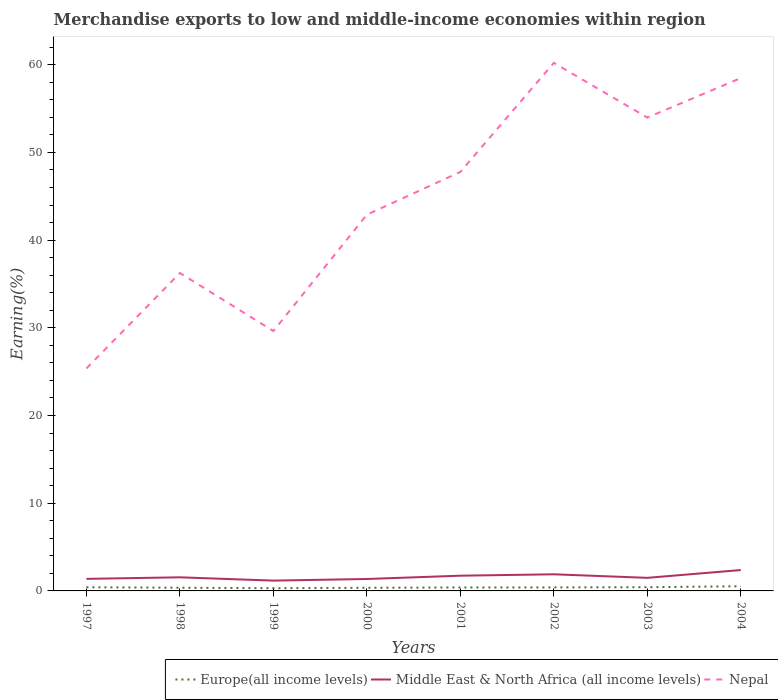How many different coloured lines are there?
Provide a short and direct response. 3. Is the number of lines equal to the number of legend labels?
Give a very brief answer. Yes. Across all years, what is the maximum percentage of amount earned from merchandise exports in Middle East & North Africa (all income levels)?
Give a very brief answer. 1.18. What is the total percentage of amount earned from merchandise exports in Nepal in the graph?
Give a very brief answer. -10.88. What is the difference between the highest and the second highest percentage of amount earned from merchandise exports in Middle East & North Africa (all income levels)?
Keep it short and to the point. 1.2. What is the difference between the highest and the lowest percentage of amount earned from merchandise exports in Europe(all income levels)?
Make the answer very short. 4. How many lines are there?
Your answer should be very brief. 3. How many years are there in the graph?
Keep it short and to the point. 8. What is the difference between two consecutive major ticks on the Y-axis?
Your response must be concise. 10. Does the graph contain any zero values?
Provide a succinct answer. No. Does the graph contain grids?
Your answer should be very brief. No. What is the title of the graph?
Your response must be concise. Merchandise exports to low and middle-income economies within region. Does "Guatemala" appear as one of the legend labels in the graph?
Provide a short and direct response. No. What is the label or title of the X-axis?
Your answer should be very brief. Years. What is the label or title of the Y-axis?
Make the answer very short. Earning(%). What is the Earning(%) in Europe(all income levels) in 1997?
Give a very brief answer. 0.42. What is the Earning(%) in Middle East & North Africa (all income levels) in 1997?
Make the answer very short. 1.38. What is the Earning(%) in Nepal in 1997?
Ensure brevity in your answer.  25.37. What is the Earning(%) in Europe(all income levels) in 1998?
Your answer should be very brief. 0.37. What is the Earning(%) of Middle East & North Africa (all income levels) in 1998?
Provide a short and direct response. 1.55. What is the Earning(%) in Nepal in 1998?
Offer a terse response. 36.25. What is the Earning(%) in Europe(all income levels) in 1999?
Your answer should be very brief. 0.31. What is the Earning(%) in Middle East & North Africa (all income levels) in 1999?
Your answer should be compact. 1.18. What is the Earning(%) in Nepal in 1999?
Keep it short and to the point. 29.63. What is the Earning(%) of Europe(all income levels) in 2000?
Give a very brief answer. 0.36. What is the Earning(%) of Middle East & North Africa (all income levels) in 2000?
Keep it short and to the point. 1.36. What is the Earning(%) in Nepal in 2000?
Provide a short and direct response. 42.9. What is the Earning(%) of Europe(all income levels) in 2001?
Offer a terse response. 0.39. What is the Earning(%) in Middle East & North Africa (all income levels) in 2001?
Ensure brevity in your answer.  1.74. What is the Earning(%) of Nepal in 2001?
Make the answer very short. 47.78. What is the Earning(%) of Europe(all income levels) in 2002?
Ensure brevity in your answer.  0.4. What is the Earning(%) of Middle East & North Africa (all income levels) in 2002?
Offer a very short reply. 1.9. What is the Earning(%) of Nepal in 2002?
Your response must be concise. 60.22. What is the Earning(%) in Europe(all income levels) in 2003?
Provide a short and direct response. 0.42. What is the Earning(%) of Middle East & North Africa (all income levels) in 2003?
Provide a succinct answer. 1.49. What is the Earning(%) in Nepal in 2003?
Offer a terse response. 53.98. What is the Earning(%) of Europe(all income levels) in 2004?
Keep it short and to the point. 0.53. What is the Earning(%) in Middle East & North Africa (all income levels) in 2004?
Provide a succinct answer. 2.38. What is the Earning(%) in Nepal in 2004?
Offer a very short reply. 58.48. Across all years, what is the maximum Earning(%) in Europe(all income levels)?
Provide a succinct answer. 0.53. Across all years, what is the maximum Earning(%) in Middle East & North Africa (all income levels)?
Keep it short and to the point. 2.38. Across all years, what is the maximum Earning(%) in Nepal?
Keep it short and to the point. 60.22. Across all years, what is the minimum Earning(%) of Europe(all income levels)?
Your answer should be very brief. 0.31. Across all years, what is the minimum Earning(%) in Middle East & North Africa (all income levels)?
Your answer should be very brief. 1.18. Across all years, what is the minimum Earning(%) of Nepal?
Give a very brief answer. 25.37. What is the total Earning(%) in Europe(all income levels) in the graph?
Your answer should be compact. 3.2. What is the total Earning(%) in Middle East & North Africa (all income levels) in the graph?
Make the answer very short. 12.97. What is the total Earning(%) of Nepal in the graph?
Your answer should be compact. 354.61. What is the difference between the Earning(%) of Europe(all income levels) in 1997 and that in 1998?
Provide a short and direct response. 0.05. What is the difference between the Earning(%) in Middle East & North Africa (all income levels) in 1997 and that in 1998?
Ensure brevity in your answer.  -0.18. What is the difference between the Earning(%) of Nepal in 1997 and that in 1998?
Offer a very short reply. -10.88. What is the difference between the Earning(%) of Europe(all income levels) in 1997 and that in 1999?
Offer a terse response. 0.11. What is the difference between the Earning(%) of Middle East & North Africa (all income levels) in 1997 and that in 1999?
Make the answer very short. 0.2. What is the difference between the Earning(%) of Nepal in 1997 and that in 1999?
Provide a succinct answer. -4.26. What is the difference between the Earning(%) in Europe(all income levels) in 1997 and that in 2000?
Offer a very short reply. 0.06. What is the difference between the Earning(%) in Middle East & North Africa (all income levels) in 1997 and that in 2000?
Give a very brief answer. 0.01. What is the difference between the Earning(%) of Nepal in 1997 and that in 2000?
Provide a succinct answer. -17.53. What is the difference between the Earning(%) in Europe(all income levels) in 1997 and that in 2001?
Ensure brevity in your answer.  0.02. What is the difference between the Earning(%) in Middle East & North Africa (all income levels) in 1997 and that in 2001?
Your response must be concise. -0.36. What is the difference between the Earning(%) of Nepal in 1997 and that in 2001?
Your response must be concise. -22.41. What is the difference between the Earning(%) of Europe(all income levels) in 1997 and that in 2002?
Your answer should be very brief. 0.02. What is the difference between the Earning(%) in Middle East & North Africa (all income levels) in 1997 and that in 2002?
Your response must be concise. -0.52. What is the difference between the Earning(%) of Nepal in 1997 and that in 2002?
Make the answer very short. -34.84. What is the difference between the Earning(%) in Europe(all income levels) in 1997 and that in 2003?
Your answer should be very brief. -0.01. What is the difference between the Earning(%) in Middle East & North Africa (all income levels) in 1997 and that in 2003?
Your answer should be very brief. -0.12. What is the difference between the Earning(%) of Nepal in 1997 and that in 2003?
Provide a short and direct response. -28.61. What is the difference between the Earning(%) of Europe(all income levels) in 1997 and that in 2004?
Your response must be concise. -0.12. What is the difference between the Earning(%) in Middle East & North Africa (all income levels) in 1997 and that in 2004?
Offer a terse response. -1. What is the difference between the Earning(%) of Nepal in 1997 and that in 2004?
Keep it short and to the point. -33.11. What is the difference between the Earning(%) in Europe(all income levels) in 1998 and that in 1999?
Your answer should be very brief. 0.06. What is the difference between the Earning(%) of Middle East & North Africa (all income levels) in 1998 and that in 1999?
Offer a very short reply. 0.38. What is the difference between the Earning(%) of Nepal in 1998 and that in 1999?
Ensure brevity in your answer.  6.61. What is the difference between the Earning(%) of Europe(all income levels) in 1998 and that in 2000?
Your answer should be compact. 0.01. What is the difference between the Earning(%) in Middle East & North Africa (all income levels) in 1998 and that in 2000?
Give a very brief answer. 0.19. What is the difference between the Earning(%) in Nepal in 1998 and that in 2000?
Give a very brief answer. -6.65. What is the difference between the Earning(%) of Europe(all income levels) in 1998 and that in 2001?
Offer a very short reply. -0.03. What is the difference between the Earning(%) of Middle East & North Africa (all income levels) in 1998 and that in 2001?
Your answer should be very brief. -0.19. What is the difference between the Earning(%) of Nepal in 1998 and that in 2001?
Make the answer very short. -11.53. What is the difference between the Earning(%) in Europe(all income levels) in 1998 and that in 2002?
Your answer should be very brief. -0.03. What is the difference between the Earning(%) in Middle East & North Africa (all income levels) in 1998 and that in 2002?
Offer a very short reply. -0.34. What is the difference between the Earning(%) in Nepal in 1998 and that in 2002?
Your answer should be compact. -23.97. What is the difference between the Earning(%) in Europe(all income levels) in 1998 and that in 2003?
Your response must be concise. -0.06. What is the difference between the Earning(%) of Middle East & North Africa (all income levels) in 1998 and that in 2003?
Keep it short and to the point. 0.06. What is the difference between the Earning(%) in Nepal in 1998 and that in 2003?
Your answer should be very brief. -17.73. What is the difference between the Earning(%) of Europe(all income levels) in 1998 and that in 2004?
Ensure brevity in your answer.  -0.17. What is the difference between the Earning(%) in Middle East & North Africa (all income levels) in 1998 and that in 2004?
Your response must be concise. -0.83. What is the difference between the Earning(%) in Nepal in 1998 and that in 2004?
Provide a short and direct response. -22.23. What is the difference between the Earning(%) of Europe(all income levels) in 1999 and that in 2000?
Offer a terse response. -0.05. What is the difference between the Earning(%) in Middle East & North Africa (all income levels) in 1999 and that in 2000?
Offer a very short reply. -0.19. What is the difference between the Earning(%) in Nepal in 1999 and that in 2000?
Your answer should be very brief. -13.27. What is the difference between the Earning(%) in Europe(all income levels) in 1999 and that in 2001?
Ensure brevity in your answer.  -0.08. What is the difference between the Earning(%) of Middle East & North Africa (all income levels) in 1999 and that in 2001?
Provide a succinct answer. -0.56. What is the difference between the Earning(%) of Nepal in 1999 and that in 2001?
Your answer should be compact. -18.14. What is the difference between the Earning(%) in Europe(all income levels) in 1999 and that in 2002?
Make the answer very short. -0.09. What is the difference between the Earning(%) in Middle East & North Africa (all income levels) in 1999 and that in 2002?
Ensure brevity in your answer.  -0.72. What is the difference between the Earning(%) of Nepal in 1999 and that in 2002?
Offer a very short reply. -30.58. What is the difference between the Earning(%) in Europe(all income levels) in 1999 and that in 2003?
Give a very brief answer. -0.12. What is the difference between the Earning(%) in Middle East & North Africa (all income levels) in 1999 and that in 2003?
Make the answer very short. -0.32. What is the difference between the Earning(%) of Nepal in 1999 and that in 2003?
Ensure brevity in your answer.  -24.34. What is the difference between the Earning(%) of Europe(all income levels) in 1999 and that in 2004?
Your response must be concise. -0.22. What is the difference between the Earning(%) of Middle East & North Africa (all income levels) in 1999 and that in 2004?
Offer a very short reply. -1.2. What is the difference between the Earning(%) in Nepal in 1999 and that in 2004?
Provide a short and direct response. -28.84. What is the difference between the Earning(%) in Europe(all income levels) in 2000 and that in 2001?
Your response must be concise. -0.03. What is the difference between the Earning(%) in Middle East & North Africa (all income levels) in 2000 and that in 2001?
Offer a terse response. -0.38. What is the difference between the Earning(%) of Nepal in 2000 and that in 2001?
Offer a terse response. -4.87. What is the difference between the Earning(%) of Europe(all income levels) in 2000 and that in 2002?
Keep it short and to the point. -0.04. What is the difference between the Earning(%) in Middle East & North Africa (all income levels) in 2000 and that in 2002?
Offer a very short reply. -0.53. What is the difference between the Earning(%) of Nepal in 2000 and that in 2002?
Keep it short and to the point. -17.31. What is the difference between the Earning(%) of Europe(all income levels) in 2000 and that in 2003?
Your answer should be compact. -0.07. What is the difference between the Earning(%) in Middle East & North Africa (all income levels) in 2000 and that in 2003?
Offer a very short reply. -0.13. What is the difference between the Earning(%) of Nepal in 2000 and that in 2003?
Your answer should be compact. -11.07. What is the difference between the Earning(%) in Europe(all income levels) in 2000 and that in 2004?
Keep it short and to the point. -0.17. What is the difference between the Earning(%) in Middle East & North Africa (all income levels) in 2000 and that in 2004?
Make the answer very short. -1.02. What is the difference between the Earning(%) in Nepal in 2000 and that in 2004?
Keep it short and to the point. -15.58. What is the difference between the Earning(%) in Europe(all income levels) in 2001 and that in 2002?
Ensure brevity in your answer.  -0.01. What is the difference between the Earning(%) of Middle East & North Africa (all income levels) in 2001 and that in 2002?
Offer a terse response. -0.16. What is the difference between the Earning(%) in Nepal in 2001 and that in 2002?
Provide a short and direct response. -12.44. What is the difference between the Earning(%) in Europe(all income levels) in 2001 and that in 2003?
Offer a very short reply. -0.03. What is the difference between the Earning(%) in Middle East & North Africa (all income levels) in 2001 and that in 2003?
Ensure brevity in your answer.  0.25. What is the difference between the Earning(%) in Nepal in 2001 and that in 2003?
Give a very brief answer. -6.2. What is the difference between the Earning(%) in Europe(all income levels) in 2001 and that in 2004?
Your answer should be compact. -0.14. What is the difference between the Earning(%) of Middle East & North Africa (all income levels) in 2001 and that in 2004?
Provide a succinct answer. -0.64. What is the difference between the Earning(%) in Nepal in 2001 and that in 2004?
Give a very brief answer. -10.7. What is the difference between the Earning(%) in Europe(all income levels) in 2002 and that in 2003?
Your answer should be very brief. -0.02. What is the difference between the Earning(%) in Middle East & North Africa (all income levels) in 2002 and that in 2003?
Keep it short and to the point. 0.4. What is the difference between the Earning(%) in Nepal in 2002 and that in 2003?
Your answer should be compact. 6.24. What is the difference between the Earning(%) in Europe(all income levels) in 2002 and that in 2004?
Keep it short and to the point. -0.13. What is the difference between the Earning(%) in Middle East & North Africa (all income levels) in 2002 and that in 2004?
Your answer should be compact. -0.48. What is the difference between the Earning(%) of Nepal in 2002 and that in 2004?
Your answer should be compact. 1.74. What is the difference between the Earning(%) of Europe(all income levels) in 2003 and that in 2004?
Your answer should be very brief. -0.11. What is the difference between the Earning(%) in Middle East & North Africa (all income levels) in 2003 and that in 2004?
Provide a succinct answer. -0.89. What is the difference between the Earning(%) of Nepal in 2003 and that in 2004?
Make the answer very short. -4.5. What is the difference between the Earning(%) in Europe(all income levels) in 1997 and the Earning(%) in Middle East & North Africa (all income levels) in 1998?
Offer a very short reply. -1.14. What is the difference between the Earning(%) in Europe(all income levels) in 1997 and the Earning(%) in Nepal in 1998?
Provide a short and direct response. -35.83. What is the difference between the Earning(%) in Middle East & North Africa (all income levels) in 1997 and the Earning(%) in Nepal in 1998?
Ensure brevity in your answer.  -34.87. What is the difference between the Earning(%) in Europe(all income levels) in 1997 and the Earning(%) in Middle East & North Africa (all income levels) in 1999?
Your answer should be compact. -0.76. What is the difference between the Earning(%) of Europe(all income levels) in 1997 and the Earning(%) of Nepal in 1999?
Provide a succinct answer. -29.22. What is the difference between the Earning(%) in Middle East & North Africa (all income levels) in 1997 and the Earning(%) in Nepal in 1999?
Your answer should be very brief. -28.26. What is the difference between the Earning(%) of Europe(all income levels) in 1997 and the Earning(%) of Middle East & North Africa (all income levels) in 2000?
Provide a short and direct response. -0.95. What is the difference between the Earning(%) of Europe(all income levels) in 1997 and the Earning(%) of Nepal in 2000?
Ensure brevity in your answer.  -42.49. What is the difference between the Earning(%) of Middle East & North Africa (all income levels) in 1997 and the Earning(%) of Nepal in 2000?
Offer a very short reply. -41.53. What is the difference between the Earning(%) in Europe(all income levels) in 1997 and the Earning(%) in Middle East & North Africa (all income levels) in 2001?
Offer a very short reply. -1.32. What is the difference between the Earning(%) in Europe(all income levels) in 1997 and the Earning(%) in Nepal in 2001?
Provide a succinct answer. -47.36. What is the difference between the Earning(%) of Middle East & North Africa (all income levels) in 1997 and the Earning(%) of Nepal in 2001?
Your answer should be compact. -46.4. What is the difference between the Earning(%) in Europe(all income levels) in 1997 and the Earning(%) in Middle East & North Africa (all income levels) in 2002?
Provide a succinct answer. -1.48. What is the difference between the Earning(%) in Europe(all income levels) in 1997 and the Earning(%) in Nepal in 2002?
Keep it short and to the point. -59.8. What is the difference between the Earning(%) in Middle East & North Africa (all income levels) in 1997 and the Earning(%) in Nepal in 2002?
Your response must be concise. -58.84. What is the difference between the Earning(%) of Europe(all income levels) in 1997 and the Earning(%) of Middle East & North Africa (all income levels) in 2003?
Provide a succinct answer. -1.08. What is the difference between the Earning(%) of Europe(all income levels) in 1997 and the Earning(%) of Nepal in 2003?
Your response must be concise. -53.56. What is the difference between the Earning(%) of Middle East & North Africa (all income levels) in 1997 and the Earning(%) of Nepal in 2003?
Keep it short and to the point. -52.6. What is the difference between the Earning(%) in Europe(all income levels) in 1997 and the Earning(%) in Middle East & North Africa (all income levels) in 2004?
Provide a succinct answer. -1.96. What is the difference between the Earning(%) in Europe(all income levels) in 1997 and the Earning(%) in Nepal in 2004?
Offer a very short reply. -58.06. What is the difference between the Earning(%) of Middle East & North Africa (all income levels) in 1997 and the Earning(%) of Nepal in 2004?
Provide a succinct answer. -57.1. What is the difference between the Earning(%) of Europe(all income levels) in 1998 and the Earning(%) of Middle East & North Africa (all income levels) in 1999?
Give a very brief answer. -0.81. What is the difference between the Earning(%) of Europe(all income levels) in 1998 and the Earning(%) of Nepal in 1999?
Your response must be concise. -29.27. What is the difference between the Earning(%) in Middle East & North Africa (all income levels) in 1998 and the Earning(%) in Nepal in 1999?
Ensure brevity in your answer.  -28.08. What is the difference between the Earning(%) of Europe(all income levels) in 1998 and the Earning(%) of Middle East & North Africa (all income levels) in 2000?
Your answer should be very brief. -1. What is the difference between the Earning(%) of Europe(all income levels) in 1998 and the Earning(%) of Nepal in 2000?
Make the answer very short. -42.54. What is the difference between the Earning(%) of Middle East & North Africa (all income levels) in 1998 and the Earning(%) of Nepal in 2000?
Ensure brevity in your answer.  -41.35. What is the difference between the Earning(%) in Europe(all income levels) in 1998 and the Earning(%) in Middle East & North Africa (all income levels) in 2001?
Provide a succinct answer. -1.37. What is the difference between the Earning(%) of Europe(all income levels) in 1998 and the Earning(%) of Nepal in 2001?
Offer a terse response. -47.41. What is the difference between the Earning(%) in Middle East & North Africa (all income levels) in 1998 and the Earning(%) in Nepal in 2001?
Keep it short and to the point. -46.22. What is the difference between the Earning(%) in Europe(all income levels) in 1998 and the Earning(%) in Middle East & North Africa (all income levels) in 2002?
Provide a short and direct response. -1.53. What is the difference between the Earning(%) of Europe(all income levels) in 1998 and the Earning(%) of Nepal in 2002?
Make the answer very short. -59.85. What is the difference between the Earning(%) in Middle East & North Africa (all income levels) in 1998 and the Earning(%) in Nepal in 2002?
Offer a very short reply. -58.66. What is the difference between the Earning(%) in Europe(all income levels) in 1998 and the Earning(%) in Middle East & North Africa (all income levels) in 2003?
Ensure brevity in your answer.  -1.13. What is the difference between the Earning(%) of Europe(all income levels) in 1998 and the Earning(%) of Nepal in 2003?
Your answer should be compact. -53.61. What is the difference between the Earning(%) in Middle East & North Africa (all income levels) in 1998 and the Earning(%) in Nepal in 2003?
Give a very brief answer. -52.42. What is the difference between the Earning(%) of Europe(all income levels) in 1998 and the Earning(%) of Middle East & North Africa (all income levels) in 2004?
Your response must be concise. -2.01. What is the difference between the Earning(%) in Europe(all income levels) in 1998 and the Earning(%) in Nepal in 2004?
Ensure brevity in your answer.  -58.11. What is the difference between the Earning(%) in Middle East & North Africa (all income levels) in 1998 and the Earning(%) in Nepal in 2004?
Provide a succinct answer. -56.93. What is the difference between the Earning(%) in Europe(all income levels) in 1999 and the Earning(%) in Middle East & North Africa (all income levels) in 2000?
Provide a succinct answer. -1.05. What is the difference between the Earning(%) of Europe(all income levels) in 1999 and the Earning(%) of Nepal in 2000?
Offer a terse response. -42.59. What is the difference between the Earning(%) of Middle East & North Africa (all income levels) in 1999 and the Earning(%) of Nepal in 2000?
Make the answer very short. -41.73. What is the difference between the Earning(%) in Europe(all income levels) in 1999 and the Earning(%) in Middle East & North Africa (all income levels) in 2001?
Offer a terse response. -1.43. What is the difference between the Earning(%) of Europe(all income levels) in 1999 and the Earning(%) of Nepal in 2001?
Offer a terse response. -47.47. What is the difference between the Earning(%) of Middle East & North Africa (all income levels) in 1999 and the Earning(%) of Nepal in 2001?
Your answer should be compact. -46.6. What is the difference between the Earning(%) of Europe(all income levels) in 1999 and the Earning(%) of Middle East & North Africa (all income levels) in 2002?
Your answer should be very brief. -1.59. What is the difference between the Earning(%) in Europe(all income levels) in 1999 and the Earning(%) in Nepal in 2002?
Offer a terse response. -59.91. What is the difference between the Earning(%) in Middle East & North Africa (all income levels) in 1999 and the Earning(%) in Nepal in 2002?
Give a very brief answer. -59.04. What is the difference between the Earning(%) of Europe(all income levels) in 1999 and the Earning(%) of Middle East & North Africa (all income levels) in 2003?
Your answer should be very brief. -1.18. What is the difference between the Earning(%) in Europe(all income levels) in 1999 and the Earning(%) in Nepal in 2003?
Offer a very short reply. -53.67. What is the difference between the Earning(%) in Middle East & North Africa (all income levels) in 1999 and the Earning(%) in Nepal in 2003?
Provide a succinct answer. -52.8. What is the difference between the Earning(%) of Europe(all income levels) in 1999 and the Earning(%) of Middle East & North Africa (all income levels) in 2004?
Your answer should be compact. -2.07. What is the difference between the Earning(%) of Europe(all income levels) in 1999 and the Earning(%) of Nepal in 2004?
Keep it short and to the point. -58.17. What is the difference between the Earning(%) in Middle East & North Africa (all income levels) in 1999 and the Earning(%) in Nepal in 2004?
Your answer should be compact. -57.3. What is the difference between the Earning(%) of Europe(all income levels) in 2000 and the Earning(%) of Middle East & North Africa (all income levels) in 2001?
Ensure brevity in your answer.  -1.38. What is the difference between the Earning(%) in Europe(all income levels) in 2000 and the Earning(%) in Nepal in 2001?
Your answer should be very brief. -47.42. What is the difference between the Earning(%) of Middle East & North Africa (all income levels) in 2000 and the Earning(%) of Nepal in 2001?
Your answer should be very brief. -46.42. What is the difference between the Earning(%) of Europe(all income levels) in 2000 and the Earning(%) of Middle East & North Africa (all income levels) in 2002?
Offer a terse response. -1.54. What is the difference between the Earning(%) of Europe(all income levels) in 2000 and the Earning(%) of Nepal in 2002?
Your answer should be very brief. -59.86. What is the difference between the Earning(%) in Middle East & North Africa (all income levels) in 2000 and the Earning(%) in Nepal in 2002?
Your answer should be compact. -58.85. What is the difference between the Earning(%) in Europe(all income levels) in 2000 and the Earning(%) in Middle East & North Africa (all income levels) in 2003?
Your answer should be very brief. -1.13. What is the difference between the Earning(%) of Europe(all income levels) in 2000 and the Earning(%) of Nepal in 2003?
Keep it short and to the point. -53.62. What is the difference between the Earning(%) in Middle East & North Africa (all income levels) in 2000 and the Earning(%) in Nepal in 2003?
Offer a terse response. -52.62. What is the difference between the Earning(%) of Europe(all income levels) in 2000 and the Earning(%) of Middle East & North Africa (all income levels) in 2004?
Your response must be concise. -2.02. What is the difference between the Earning(%) of Europe(all income levels) in 2000 and the Earning(%) of Nepal in 2004?
Your answer should be compact. -58.12. What is the difference between the Earning(%) of Middle East & North Africa (all income levels) in 2000 and the Earning(%) of Nepal in 2004?
Offer a very short reply. -57.12. What is the difference between the Earning(%) in Europe(all income levels) in 2001 and the Earning(%) in Middle East & North Africa (all income levels) in 2002?
Your answer should be compact. -1.5. What is the difference between the Earning(%) in Europe(all income levels) in 2001 and the Earning(%) in Nepal in 2002?
Make the answer very short. -59.82. What is the difference between the Earning(%) of Middle East & North Africa (all income levels) in 2001 and the Earning(%) of Nepal in 2002?
Make the answer very short. -58.48. What is the difference between the Earning(%) in Europe(all income levels) in 2001 and the Earning(%) in Middle East & North Africa (all income levels) in 2003?
Your response must be concise. -1.1. What is the difference between the Earning(%) in Europe(all income levels) in 2001 and the Earning(%) in Nepal in 2003?
Ensure brevity in your answer.  -53.58. What is the difference between the Earning(%) in Middle East & North Africa (all income levels) in 2001 and the Earning(%) in Nepal in 2003?
Give a very brief answer. -52.24. What is the difference between the Earning(%) in Europe(all income levels) in 2001 and the Earning(%) in Middle East & North Africa (all income levels) in 2004?
Provide a short and direct response. -1.99. What is the difference between the Earning(%) of Europe(all income levels) in 2001 and the Earning(%) of Nepal in 2004?
Provide a succinct answer. -58.09. What is the difference between the Earning(%) of Middle East & North Africa (all income levels) in 2001 and the Earning(%) of Nepal in 2004?
Ensure brevity in your answer.  -56.74. What is the difference between the Earning(%) in Europe(all income levels) in 2002 and the Earning(%) in Middle East & North Africa (all income levels) in 2003?
Make the answer very short. -1.09. What is the difference between the Earning(%) in Europe(all income levels) in 2002 and the Earning(%) in Nepal in 2003?
Make the answer very short. -53.58. What is the difference between the Earning(%) in Middle East & North Africa (all income levels) in 2002 and the Earning(%) in Nepal in 2003?
Offer a terse response. -52.08. What is the difference between the Earning(%) in Europe(all income levels) in 2002 and the Earning(%) in Middle East & North Africa (all income levels) in 2004?
Offer a terse response. -1.98. What is the difference between the Earning(%) of Europe(all income levels) in 2002 and the Earning(%) of Nepal in 2004?
Ensure brevity in your answer.  -58.08. What is the difference between the Earning(%) in Middle East & North Africa (all income levels) in 2002 and the Earning(%) in Nepal in 2004?
Ensure brevity in your answer.  -56.58. What is the difference between the Earning(%) in Europe(all income levels) in 2003 and the Earning(%) in Middle East & North Africa (all income levels) in 2004?
Make the answer very short. -1.96. What is the difference between the Earning(%) of Europe(all income levels) in 2003 and the Earning(%) of Nepal in 2004?
Offer a terse response. -58.05. What is the difference between the Earning(%) in Middle East & North Africa (all income levels) in 2003 and the Earning(%) in Nepal in 2004?
Provide a succinct answer. -56.99. What is the average Earning(%) in Europe(all income levels) per year?
Provide a succinct answer. 0.4. What is the average Earning(%) of Middle East & North Africa (all income levels) per year?
Your response must be concise. 1.62. What is the average Earning(%) of Nepal per year?
Provide a succinct answer. 44.33. In the year 1997, what is the difference between the Earning(%) in Europe(all income levels) and Earning(%) in Middle East & North Africa (all income levels)?
Offer a terse response. -0.96. In the year 1997, what is the difference between the Earning(%) in Europe(all income levels) and Earning(%) in Nepal?
Provide a succinct answer. -24.95. In the year 1997, what is the difference between the Earning(%) in Middle East & North Africa (all income levels) and Earning(%) in Nepal?
Make the answer very short. -24. In the year 1998, what is the difference between the Earning(%) of Europe(all income levels) and Earning(%) of Middle East & North Africa (all income levels)?
Ensure brevity in your answer.  -1.19. In the year 1998, what is the difference between the Earning(%) of Europe(all income levels) and Earning(%) of Nepal?
Give a very brief answer. -35.88. In the year 1998, what is the difference between the Earning(%) in Middle East & North Africa (all income levels) and Earning(%) in Nepal?
Your answer should be very brief. -34.7. In the year 1999, what is the difference between the Earning(%) of Europe(all income levels) and Earning(%) of Middle East & North Africa (all income levels)?
Your answer should be compact. -0.87. In the year 1999, what is the difference between the Earning(%) of Europe(all income levels) and Earning(%) of Nepal?
Provide a succinct answer. -29.33. In the year 1999, what is the difference between the Earning(%) in Middle East & North Africa (all income levels) and Earning(%) in Nepal?
Provide a succinct answer. -28.46. In the year 2000, what is the difference between the Earning(%) in Europe(all income levels) and Earning(%) in Middle East & North Africa (all income levels)?
Give a very brief answer. -1. In the year 2000, what is the difference between the Earning(%) in Europe(all income levels) and Earning(%) in Nepal?
Provide a succinct answer. -42.54. In the year 2000, what is the difference between the Earning(%) in Middle East & North Africa (all income levels) and Earning(%) in Nepal?
Your answer should be very brief. -41.54. In the year 2001, what is the difference between the Earning(%) in Europe(all income levels) and Earning(%) in Middle East & North Africa (all income levels)?
Make the answer very short. -1.35. In the year 2001, what is the difference between the Earning(%) in Europe(all income levels) and Earning(%) in Nepal?
Your response must be concise. -47.38. In the year 2001, what is the difference between the Earning(%) in Middle East & North Africa (all income levels) and Earning(%) in Nepal?
Make the answer very short. -46.04. In the year 2002, what is the difference between the Earning(%) in Europe(all income levels) and Earning(%) in Middle East & North Africa (all income levels)?
Provide a succinct answer. -1.5. In the year 2002, what is the difference between the Earning(%) in Europe(all income levels) and Earning(%) in Nepal?
Make the answer very short. -59.82. In the year 2002, what is the difference between the Earning(%) of Middle East & North Africa (all income levels) and Earning(%) of Nepal?
Offer a terse response. -58.32. In the year 2003, what is the difference between the Earning(%) in Europe(all income levels) and Earning(%) in Middle East & North Africa (all income levels)?
Give a very brief answer. -1.07. In the year 2003, what is the difference between the Earning(%) of Europe(all income levels) and Earning(%) of Nepal?
Provide a succinct answer. -53.55. In the year 2003, what is the difference between the Earning(%) of Middle East & North Africa (all income levels) and Earning(%) of Nepal?
Make the answer very short. -52.48. In the year 2004, what is the difference between the Earning(%) in Europe(all income levels) and Earning(%) in Middle East & North Africa (all income levels)?
Offer a terse response. -1.85. In the year 2004, what is the difference between the Earning(%) in Europe(all income levels) and Earning(%) in Nepal?
Ensure brevity in your answer.  -57.95. In the year 2004, what is the difference between the Earning(%) of Middle East & North Africa (all income levels) and Earning(%) of Nepal?
Give a very brief answer. -56.1. What is the ratio of the Earning(%) in Europe(all income levels) in 1997 to that in 1998?
Offer a very short reply. 1.14. What is the ratio of the Earning(%) of Middle East & North Africa (all income levels) in 1997 to that in 1998?
Give a very brief answer. 0.89. What is the ratio of the Earning(%) of Nepal in 1997 to that in 1998?
Provide a short and direct response. 0.7. What is the ratio of the Earning(%) of Europe(all income levels) in 1997 to that in 1999?
Make the answer very short. 1.35. What is the ratio of the Earning(%) in Middle East & North Africa (all income levels) in 1997 to that in 1999?
Keep it short and to the point. 1.17. What is the ratio of the Earning(%) of Nepal in 1997 to that in 1999?
Ensure brevity in your answer.  0.86. What is the ratio of the Earning(%) in Europe(all income levels) in 1997 to that in 2000?
Your answer should be compact. 1.16. What is the ratio of the Earning(%) in Middle East & North Africa (all income levels) in 1997 to that in 2000?
Offer a terse response. 1.01. What is the ratio of the Earning(%) of Nepal in 1997 to that in 2000?
Your answer should be very brief. 0.59. What is the ratio of the Earning(%) of Europe(all income levels) in 1997 to that in 2001?
Give a very brief answer. 1.06. What is the ratio of the Earning(%) of Middle East & North Africa (all income levels) in 1997 to that in 2001?
Make the answer very short. 0.79. What is the ratio of the Earning(%) of Nepal in 1997 to that in 2001?
Give a very brief answer. 0.53. What is the ratio of the Earning(%) in Europe(all income levels) in 1997 to that in 2002?
Provide a short and direct response. 1.04. What is the ratio of the Earning(%) of Middle East & North Africa (all income levels) in 1997 to that in 2002?
Give a very brief answer. 0.73. What is the ratio of the Earning(%) in Nepal in 1997 to that in 2002?
Offer a very short reply. 0.42. What is the ratio of the Earning(%) of Europe(all income levels) in 1997 to that in 2003?
Offer a terse response. 0.98. What is the ratio of the Earning(%) in Middle East & North Africa (all income levels) in 1997 to that in 2003?
Your answer should be compact. 0.92. What is the ratio of the Earning(%) of Nepal in 1997 to that in 2003?
Keep it short and to the point. 0.47. What is the ratio of the Earning(%) in Europe(all income levels) in 1997 to that in 2004?
Offer a terse response. 0.78. What is the ratio of the Earning(%) of Middle East & North Africa (all income levels) in 1997 to that in 2004?
Offer a very short reply. 0.58. What is the ratio of the Earning(%) of Nepal in 1997 to that in 2004?
Your response must be concise. 0.43. What is the ratio of the Earning(%) in Europe(all income levels) in 1998 to that in 1999?
Keep it short and to the point. 1.19. What is the ratio of the Earning(%) in Middle East & North Africa (all income levels) in 1998 to that in 1999?
Keep it short and to the point. 1.32. What is the ratio of the Earning(%) in Nepal in 1998 to that in 1999?
Ensure brevity in your answer.  1.22. What is the ratio of the Earning(%) of Europe(all income levels) in 1998 to that in 2000?
Provide a succinct answer. 1.02. What is the ratio of the Earning(%) in Middle East & North Africa (all income levels) in 1998 to that in 2000?
Keep it short and to the point. 1.14. What is the ratio of the Earning(%) of Nepal in 1998 to that in 2000?
Ensure brevity in your answer.  0.84. What is the ratio of the Earning(%) of Europe(all income levels) in 1998 to that in 2001?
Your response must be concise. 0.93. What is the ratio of the Earning(%) in Middle East & North Africa (all income levels) in 1998 to that in 2001?
Give a very brief answer. 0.89. What is the ratio of the Earning(%) of Nepal in 1998 to that in 2001?
Make the answer very short. 0.76. What is the ratio of the Earning(%) of Europe(all income levels) in 1998 to that in 2002?
Give a very brief answer. 0.91. What is the ratio of the Earning(%) of Middle East & North Africa (all income levels) in 1998 to that in 2002?
Your response must be concise. 0.82. What is the ratio of the Earning(%) of Nepal in 1998 to that in 2002?
Offer a very short reply. 0.6. What is the ratio of the Earning(%) of Europe(all income levels) in 1998 to that in 2003?
Give a very brief answer. 0.86. What is the ratio of the Earning(%) in Middle East & North Africa (all income levels) in 1998 to that in 2003?
Your answer should be compact. 1.04. What is the ratio of the Earning(%) of Nepal in 1998 to that in 2003?
Give a very brief answer. 0.67. What is the ratio of the Earning(%) in Europe(all income levels) in 1998 to that in 2004?
Your answer should be very brief. 0.69. What is the ratio of the Earning(%) in Middle East & North Africa (all income levels) in 1998 to that in 2004?
Your answer should be very brief. 0.65. What is the ratio of the Earning(%) in Nepal in 1998 to that in 2004?
Give a very brief answer. 0.62. What is the ratio of the Earning(%) of Europe(all income levels) in 1999 to that in 2000?
Your answer should be compact. 0.86. What is the ratio of the Earning(%) in Middle East & North Africa (all income levels) in 1999 to that in 2000?
Ensure brevity in your answer.  0.86. What is the ratio of the Earning(%) in Nepal in 1999 to that in 2000?
Offer a very short reply. 0.69. What is the ratio of the Earning(%) of Europe(all income levels) in 1999 to that in 2001?
Provide a short and direct response. 0.79. What is the ratio of the Earning(%) in Middle East & North Africa (all income levels) in 1999 to that in 2001?
Give a very brief answer. 0.68. What is the ratio of the Earning(%) in Nepal in 1999 to that in 2001?
Keep it short and to the point. 0.62. What is the ratio of the Earning(%) of Europe(all income levels) in 1999 to that in 2002?
Offer a very short reply. 0.77. What is the ratio of the Earning(%) in Middle East & North Africa (all income levels) in 1999 to that in 2002?
Your response must be concise. 0.62. What is the ratio of the Earning(%) in Nepal in 1999 to that in 2002?
Make the answer very short. 0.49. What is the ratio of the Earning(%) of Europe(all income levels) in 1999 to that in 2003?
Keep it short and to the point. 0.73. What is the ratio of the Earning(%) of Middle East & North Africa (all income levels) in 1999 to that in 2003?
Your answer should be compact. 0.79. What is the ratio of the Earning(%) of Nepal in 1999 to that in 2003?
Provide a short and direct response. 0.55. What is the ratio of the Earning(%) in Europe(all income levels) in 1999 to that in 2004?
Offer a terse response. 0.58. What is the ratio of the Earning(%) in Middle East & North Africa (all income levels) in 1999 to that in 2004?
Your answer should be compact. 0.49. What is the ratio of the Earning(%) in Nepal in 1999 to that in 2004?
Give a very brief answer. 0.51. What is the ratio of the Earning(%) of Europe(all income levels) in 2000 to that in 2001?
Keep it short and to the point. 0.91. What is the ratio of the Earning(%) of Middle East & North Africa (all income levels) in 2000 to that in 2001?
Your response must be concise. 0.78. What is the ratio of the Earning(%) in Nepal in 2000 to that in 2001?
Offer a terse response. 0.9. What is the ratio of the Earning(%) in Europe(all income levels) in 2000 to that in 2002?
Your response must be concise. 0.9. What is the ratio of the Earning(%) in Middle East & North Africa (all income levels) in 2000 to that in 2002?
Offer a terse response. 0.72. What is the ratio of the Earning(%) of Nepal in 2000 to that in 2002?
Your answer should be very brief. 0.71. What is the ratio of the Earning(%) in Europe(all income levels) in 2000 to that in 2003?
Offer a terse response. 0.85. What is the ratio of the Earning(%) in Middle East & North Africa (all income levels) in 2000 to that in 2003?
Offer a terse response. 0.91. What is the ratio of the Earning(%) in Nepal in 2000 to that in 2003?
Your answer should be very brief. 0.79. What is the ratio of the Earning(%) in Europe(all income levels) in 2000 to that in 2004?
Provide a succinct answer. 0.67. What is the ratio of the Earning(%) of Middle East & North Africa (all income levels) in 2000 to that in 2004?
Offer a very short reply. 0.57. What is the ratio of the Earning(%) of Nepal in 2000 to that in 2004?
Your answer should be very brief. 0.73. What is the ratio of the Earning(%) in Europe(all income levels) in 2001 to that in 2002?
Your answer should be very brief. 0.98. What is the ratio of the Earning(%) in Middle East & North Africa (all income levels) in 2001 to that in 2002?
Provide a succinct answer. 0.92. What is the ratio of the Earning(%) of Nepal in 2001 to that in 2002?
Provide a succinct answer. 0.79. What is the ratio of the Earning(%) of Europe(all income levels) in 2001 to that in 2003?
Your answer should be very brief. 0.93. What is the ratio of the Earning(%) of Middle East & North Africa (all income levels) in 2001 to that in 2003?
Your response must be concise. 1.16. What is the ratio of the Earning(%) in Nepal in 2001 to that in 2003?
Your response must be concise. 0.89. What is the ratio of the Earning(%) of Europe(all income levels) in 2001 to that in 2004?
Your answer should be very brief. 0.74. What is the ratio of the Earning(%) of Middle East & North Africa (all income levels) in 2001 to that in 2004?
Ensure brevity in your answer.  0.73. What is the ratio of the Earning(%) of Nepal in 2001 to that in 2004?
Offer a terse response. 0.82. What is the ratio of the Earning(%) of Europe(all income levels) in 2002 to that in 2003?
Make the answer very short. 0.94. What is the ratio of the Earning(%) of Middle East & North Africa (all income levels) in 2002 to that in 2003?
Provide a succinct answer. 1.27. What is the ratio of the Earning(%) in Nepal in 2002 to that in 2003?
Offer a very short reply. 1.12. What is the ratio of the Earning(%) of Europe(all income levels) in 2002 to that in 2004?
Your response must be concise. 0.75. What is the ratio of the Earning(%) in Middle East & North Africa (all income levels) in 2002 to that in 2004?
Your response must be concise. 0.8. What is the ratio of the Earning(%) in Nepal in 2002 to that in 2004?
Your response must be concise. 1.03. What is the ratio of the Earning(%) in Europe(all income levels) in 2003 to that in 2004?
Offer a terse response. 0.8. What is the ratio of the Earning(%) of Middle East & North Africa (all income levels) in 2003 to that in 2004?
Keep it short and to the point. 0.63. What is the ratio of the Earning(%) in Nepal in 2003 to that in 2004?
Your response must be concise. 0.92. What is the difference between the highest and the second highest Earning(%) in Europe(all income levels)?
Keep it short and to the point. 0.11. What is the difference between the highest and the second highest Earning(%) of Middle East & North Africa (all income levels)?
Make the answer very short. 0.48. What is the difference between the highest and the second highest Earning(%) in Nepal?
Ensure brevity in your answer.  1.74. What is the difference between the highest and the lowest Earning(%) in Europe(all income levels)?
Give a very brief answer. 0.22. What is the difference between the highest and the lowest Earning(%) of Middle East & North Africa (all income levels)?
Your answer should be very brief. 1.2. What is the difference between the highest and the lowest Earning(%) in Nepal?
Give a very brief answer. 34.84. 